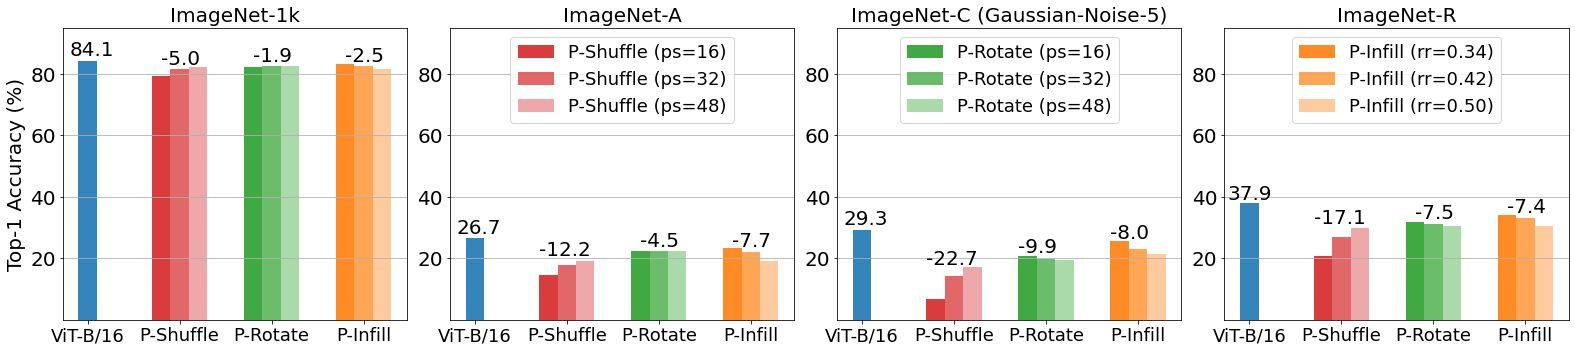In practical applications, how could understanding these perturbation impacts benefit AI model deployment? Understanding the impacts of different perturbation techniques on AI models, such as ViT-B/16, is crucial for optimizing their performance in real-world scenarios, especially in environments with visual noise or distortions. By selecting the most robust perturbation technique, developers can enhance the model's accuracy and reliability, leading to improved user experiences and more effective solutions in various applications, from automated driving systems to medical image analysis. 